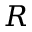<formula> <loc_0><loc_0><loc_500><loc_500>R</formula> 